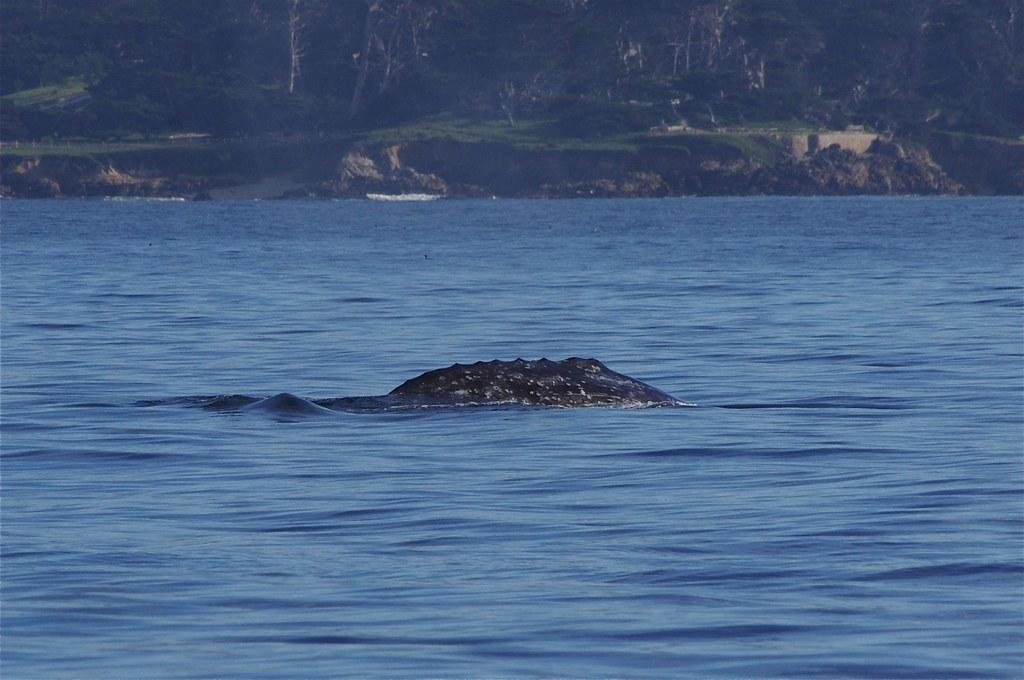What is visible at the bottom of the image? There is water visible at the bottom of the image. What animal can be seen in the water? An alligator appears to be in the water. What type of vegetation is visible in the background of the image? There are trees and grass visible in the background of the image. What color is the blood on the alligator's partner in the image? There is no blood or partner present in the image; it features an alligator in water with trees and grass in the background. 